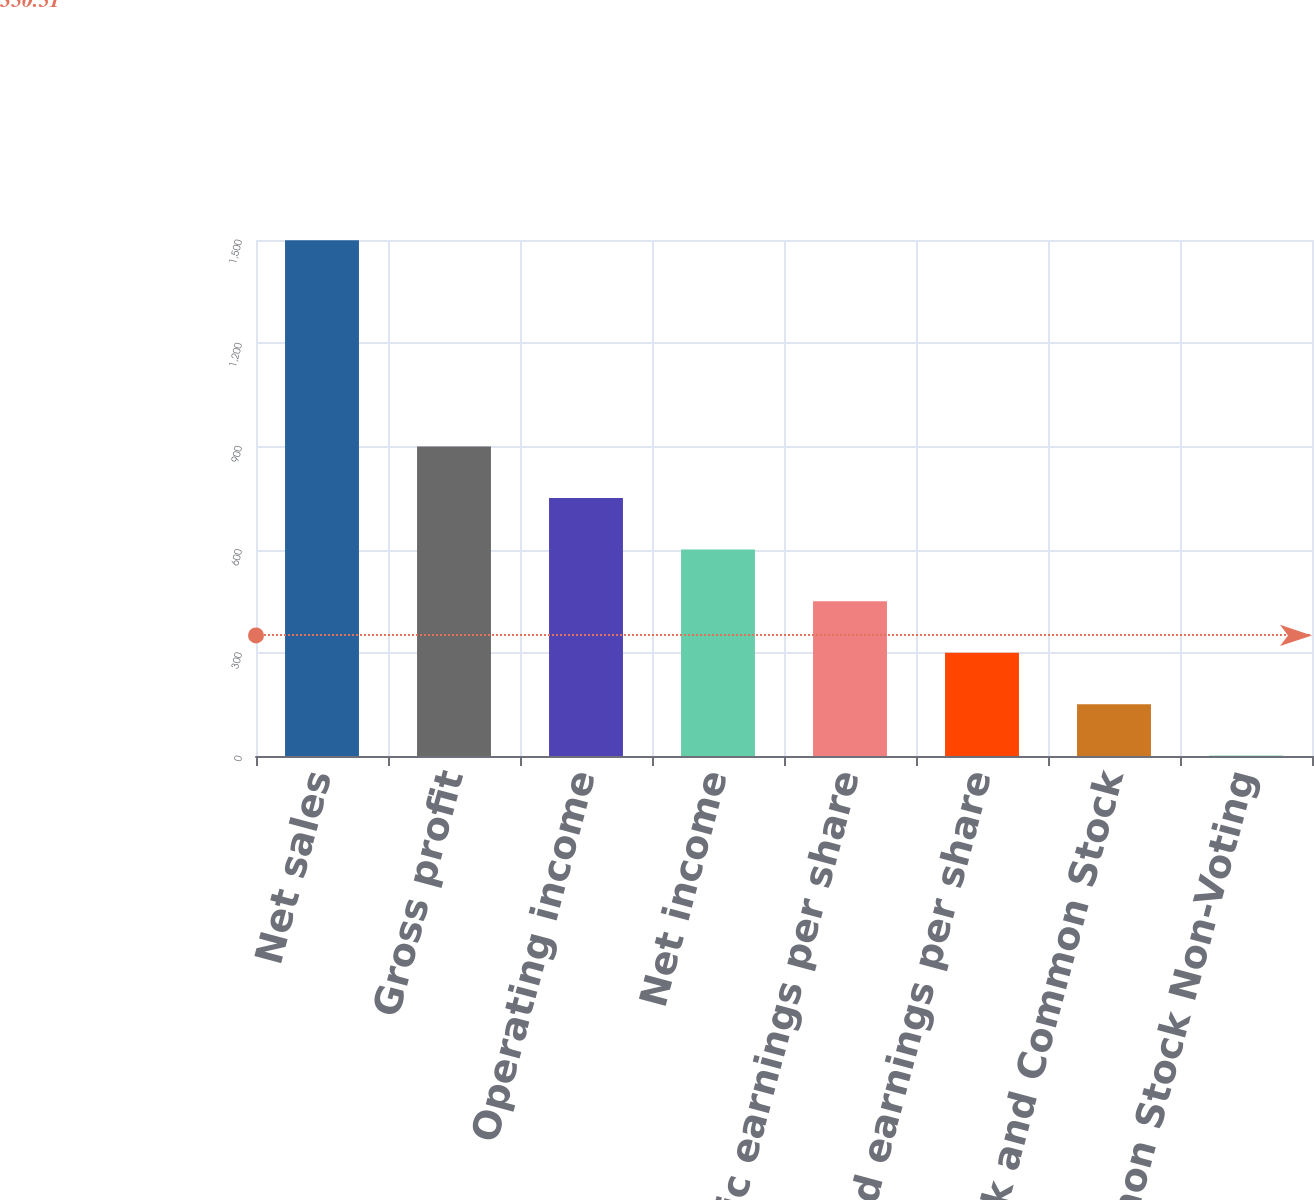Convert chart. <chart><loc_0><loc_0><loc_500><loc_500><bar_chart><fcel>Net sales<fcel>Gross profit<fcel>Operating income<fcel>Net income<fcel>Basic earnings per share<fcel>Diluted earnings per share<fcel>Common Stock and Common Stock<fcel>Common Stock Non-Voting<nl><fcel>1499.2<fcel>899.69<fcel>749.82<fcel>599.95<fcel>450.08<fcel>300.21<fcel>150.34<fcel>0.47<nl></chart> 